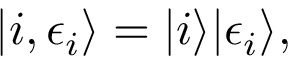<formula> <loc_0><loc_0><loc_500><loc_500>| i , \epsilon _ { i } \rangle = | i \rangle | \epsilon _ { i } \rangle ,</formula> 